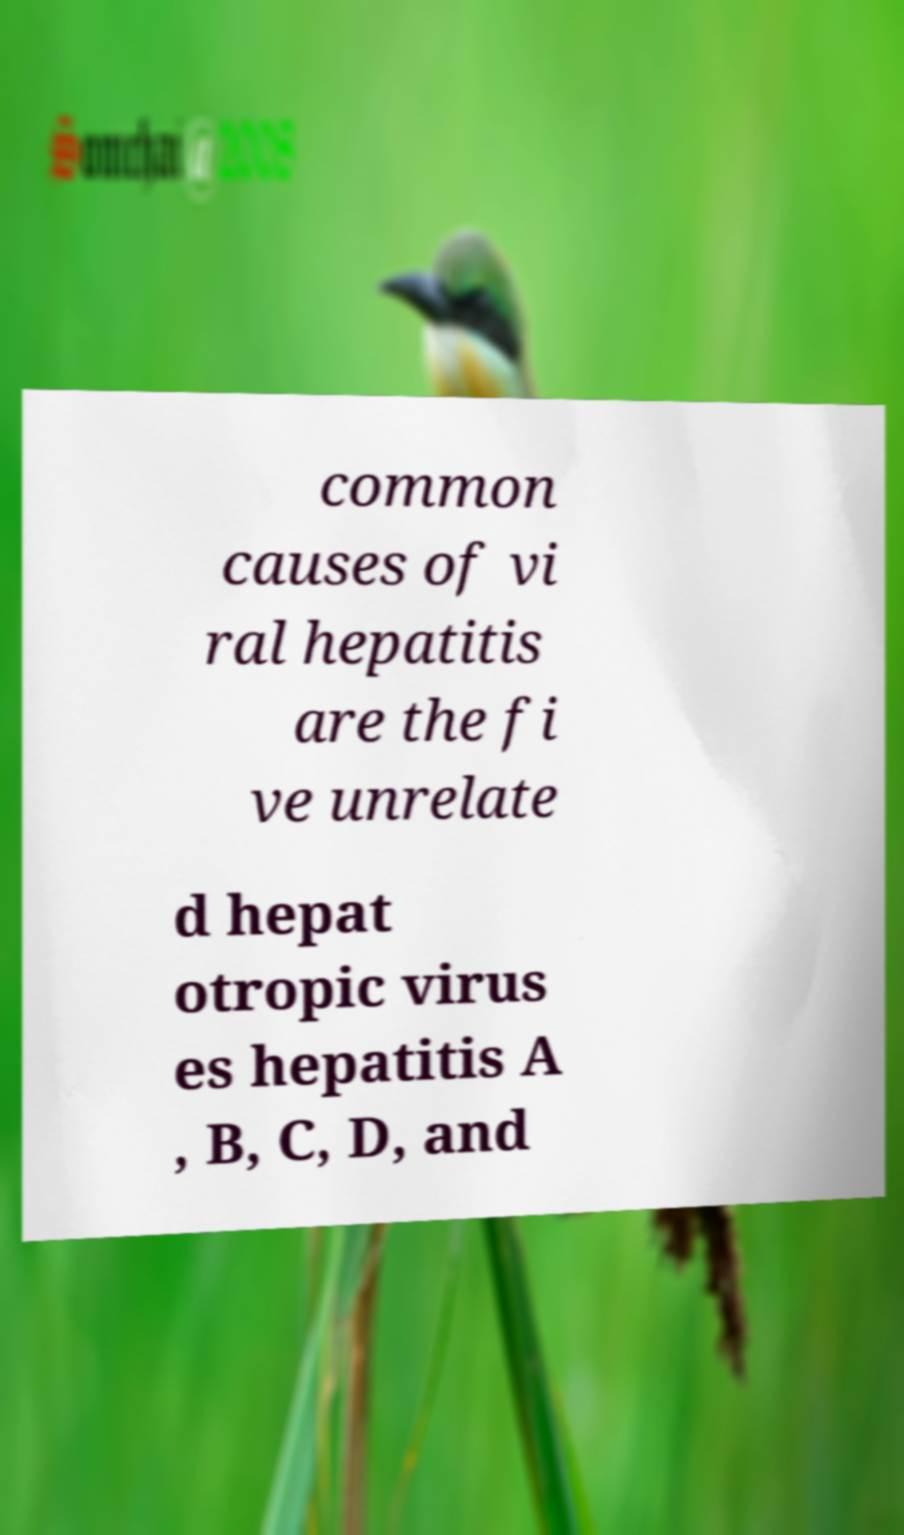There's text embedded in this image that I need extracted. Can you transcribe it verbatim? common causes of vi ral hepatitis are the fi ve unrelate d hepat otropic virus es hepatitis A , B, C, D, and 